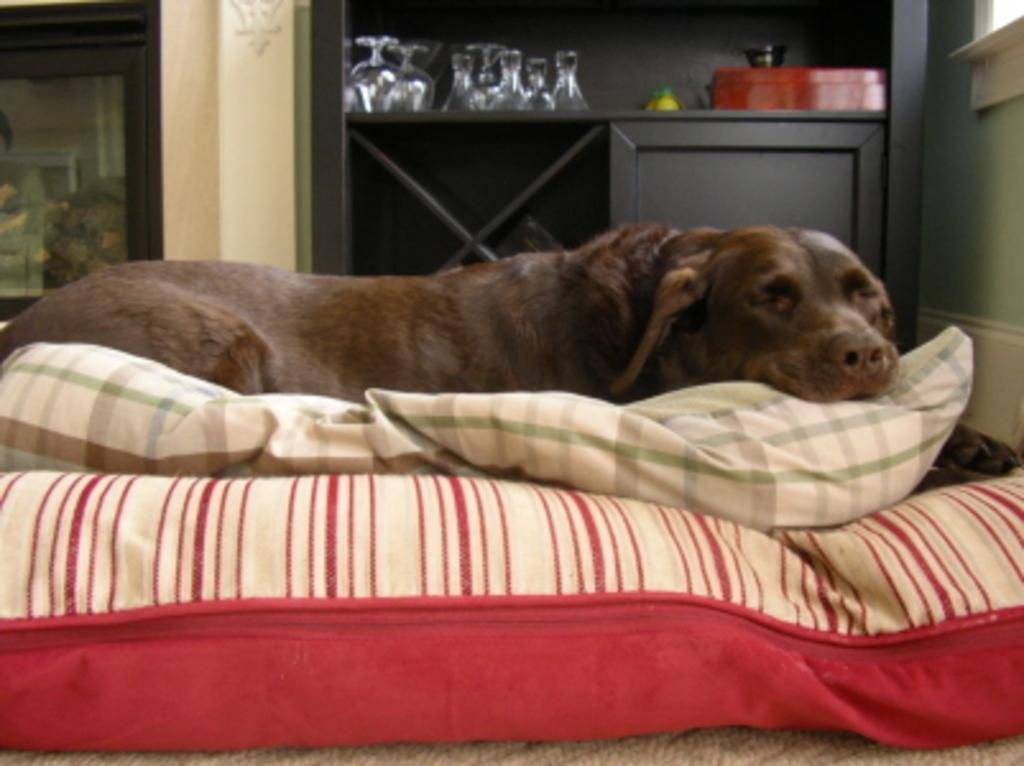What is the dog doing in the image? The dog is lying on a bed in the image. What can be seen in the background of the image? There is a door visible in the image. What is hanging on the wall in the image? There is a decoration on a wall in the image. What objects are present for drinking purposes in the image? There are glasses present in the image. What items are stacked on a surface in the image? There are boxes placed on a surface in the image. What type of furniture is visible in the image? There is a cupboard in the image. How many bikes are parked next to the cupboard in the image? There are no bikes present in the image. What type of sweater is the dog wearing in the image? The dog is not wearing a sweater in the image; it is lying on a bed without any clothing. 